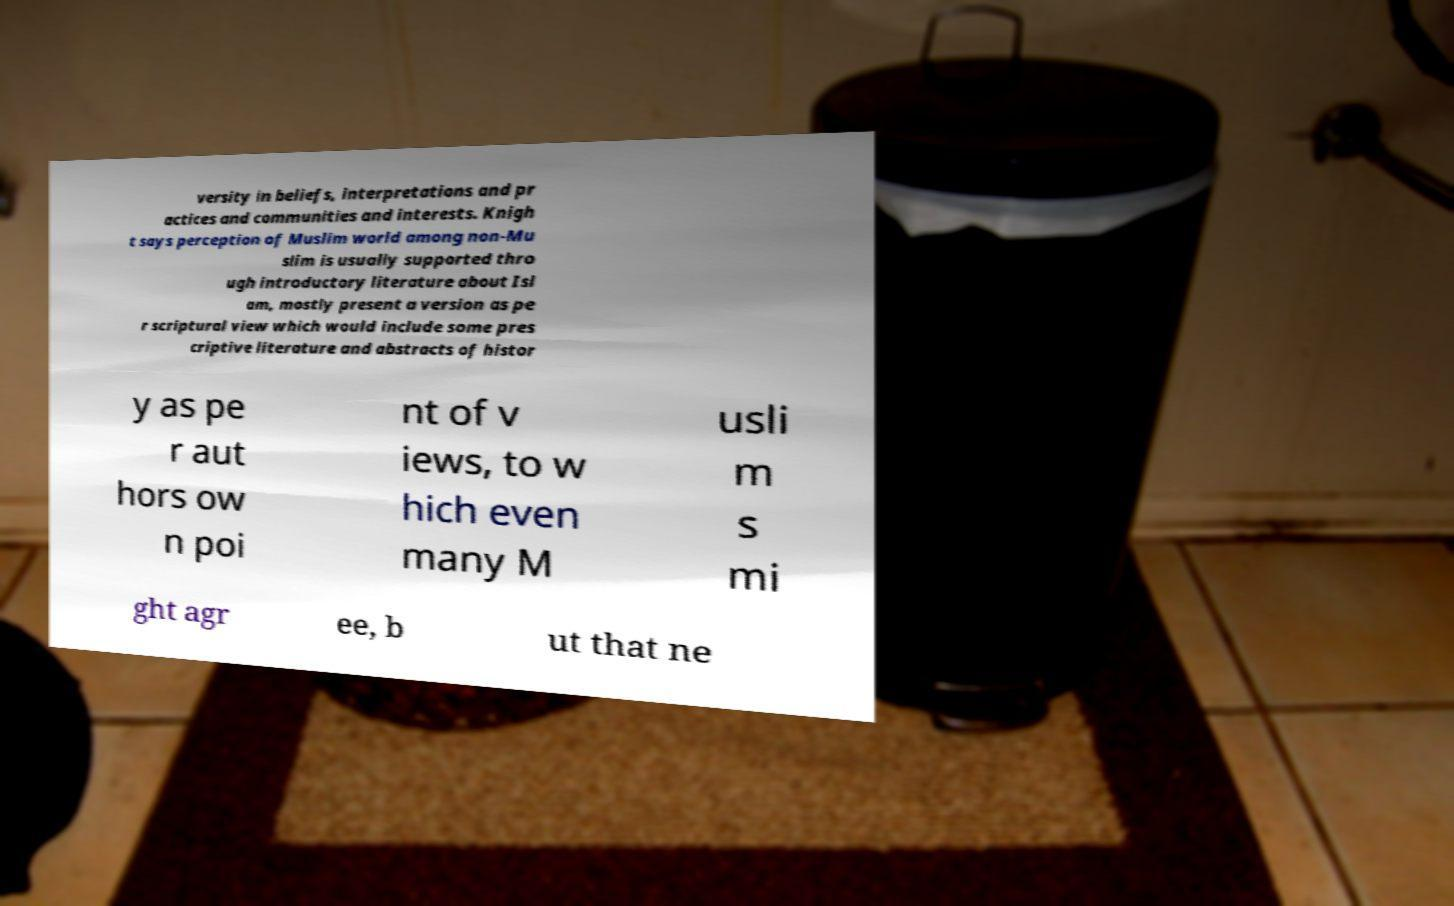Could you assist in decoding the text presented in this image and type it out clearly? versity in beliefs, interpretations and pr actices and communities and interests. Knigh t says perception of Muslim world among non-Mu slim is usually supported thro ugh introductory literature about Isl am, mostly present a version as pe r scriptural view which would include some pres criptive literature and abstracts of histor y as pe r aut hors ow n poi nt of v iews, to w hich even many M usli m s mi ght agr ee, b ut that ne 